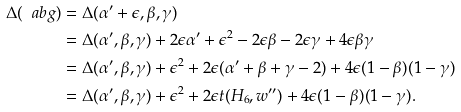<formula> <loc_0><loc_0><loc_500><loc_500>\Delta ( \ a b g ) & = \Delta ( \alpha ^ { \prime } + \epsilon , \beta , \gamma ) \\ & = \Delta ( \alpha ^ { \prime } , \beta , \gamma ) + 2 \epsilon \alpha ^ { \prime } + \epsilon ^ { 2 } - 2 \epsilon \beta - 2 \epsilon \gamma + 4 \epsilon \beta \gamma \\ & = \Delta ( \alpha ^ { \prime } , \beta , \gamma ) + \epsilon ^ { 2 } + 2 \epsilon ( \alpha ^ { \prime } + \beta + \gamma - 2 ) + 4 \epsilon ( 1 - \beta ) ( 1 - \gamma ) \\ & = \Delta ( \alpha ^ { \prime } , \beta , \gamma ) + \epsilon ^ { 2 } + 2 \epsilon t ( H _ { 6 } , w ^ { \prime \prime } ) + 4 \epsilon ( 1 - \beta ) ( 1 - \gamma ) .</formula> 